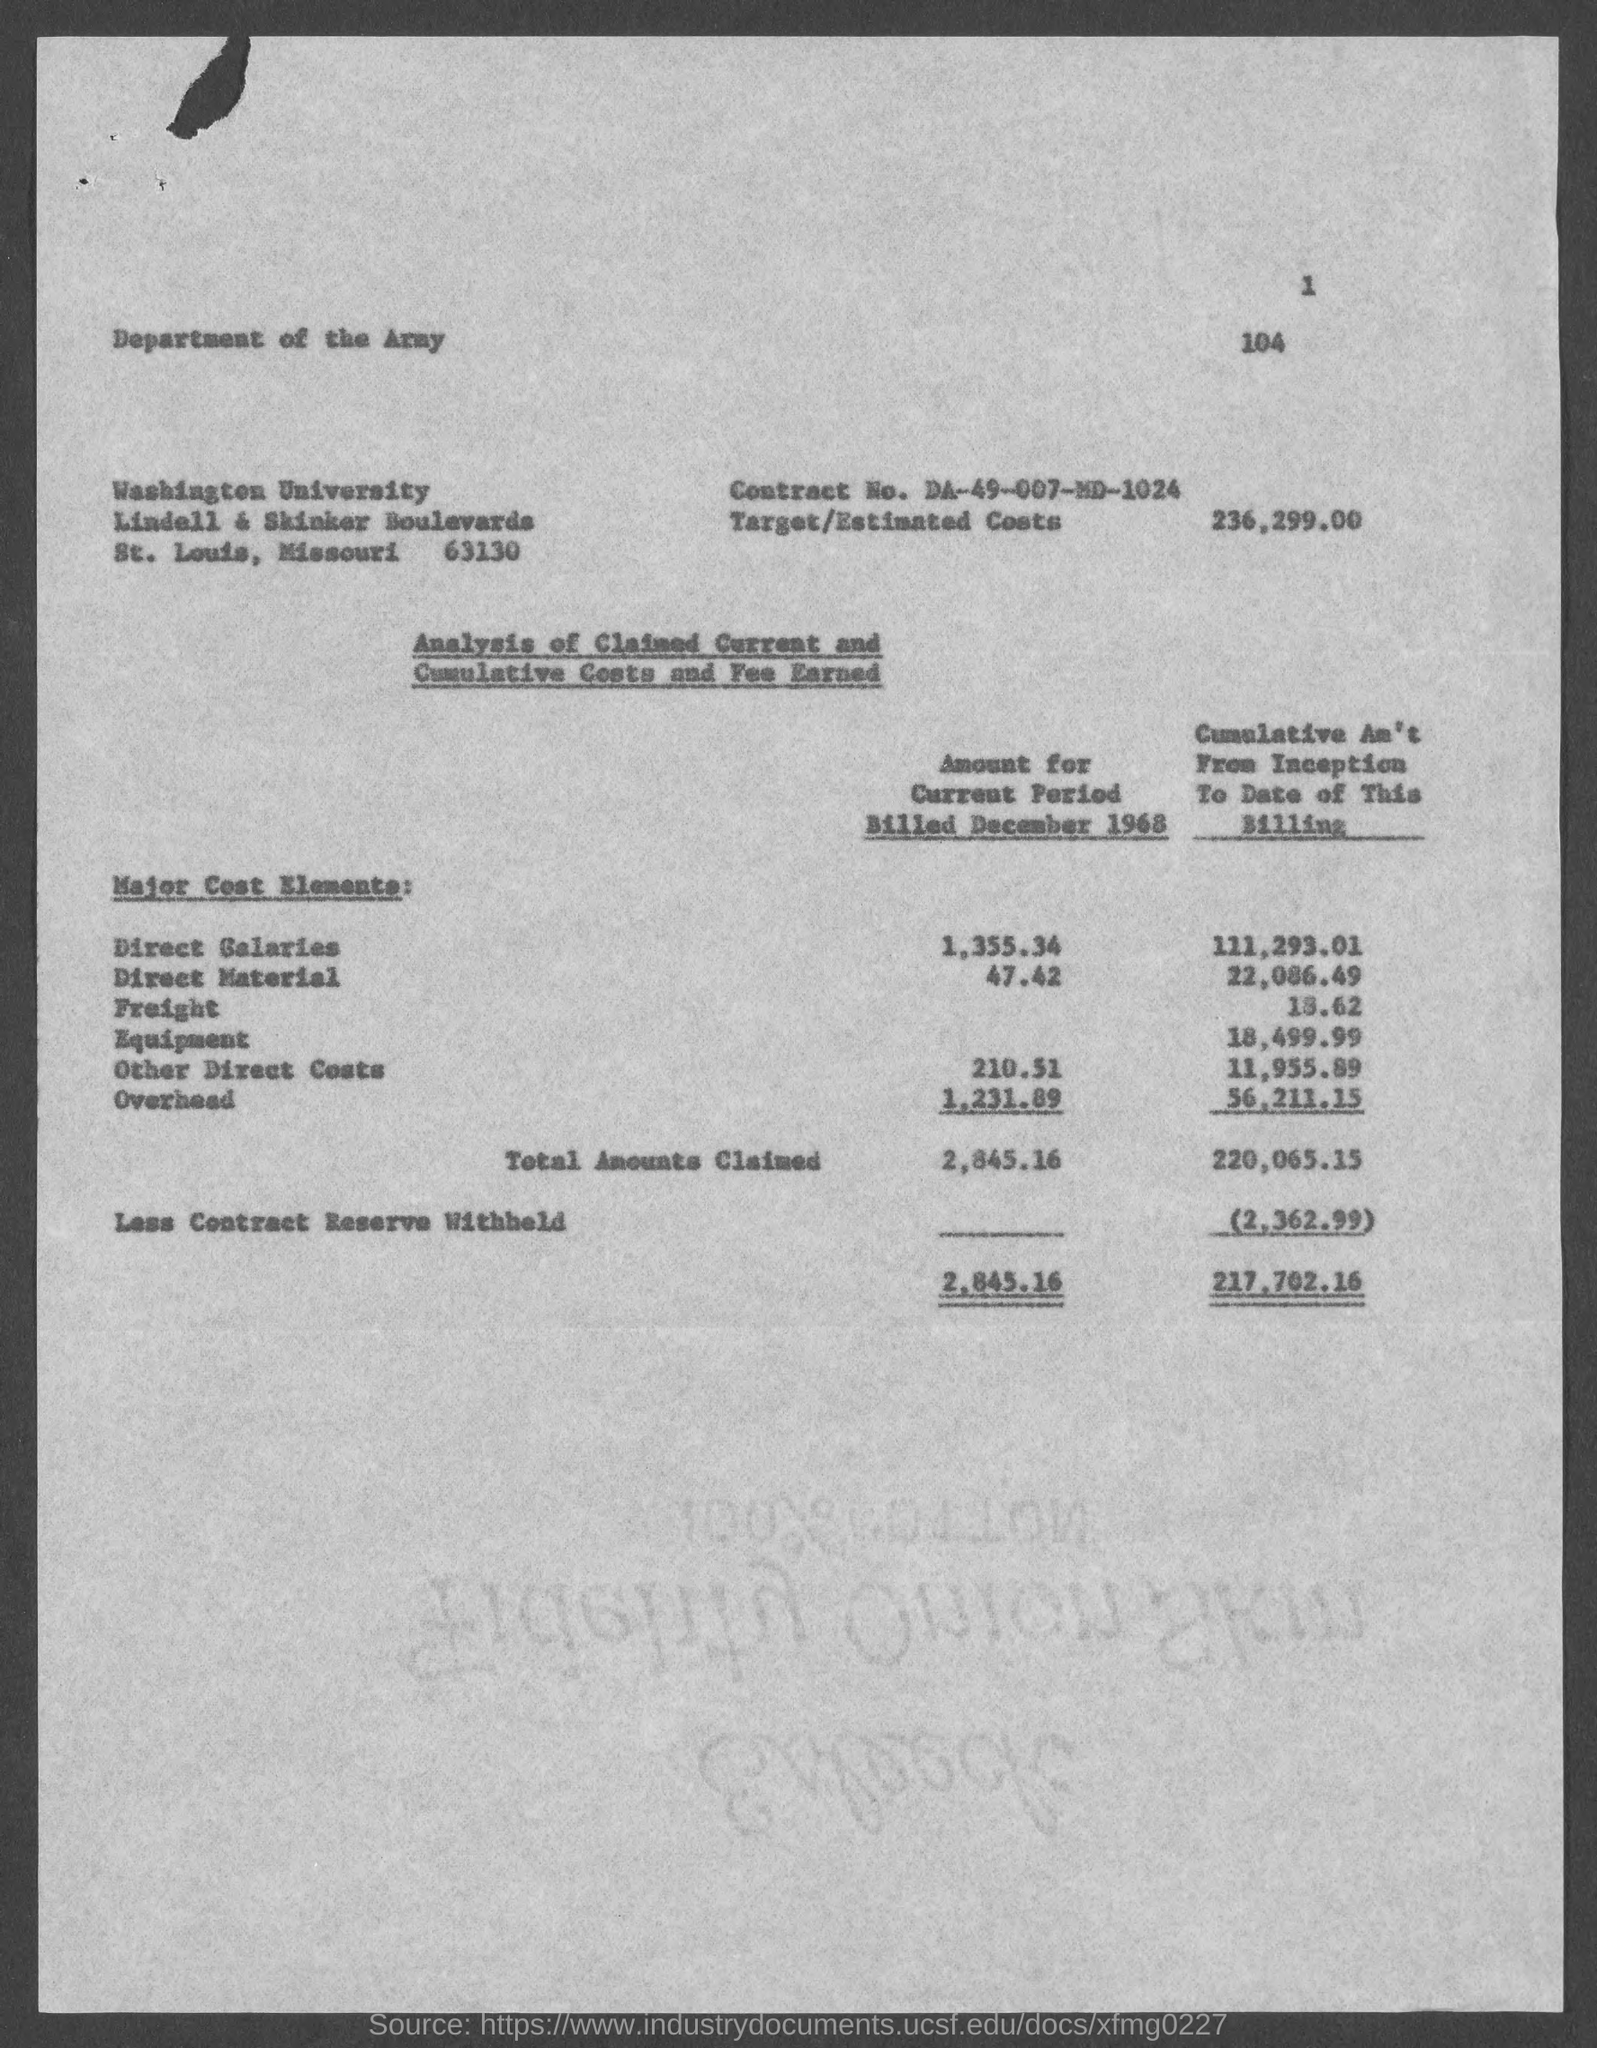What is Contract No.?
Your answer should be compact. DA-49-007-MD-1024. What is the target/estimated costs?
Give a very brief answer. 236,299.00. 